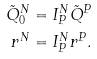Convert formula to latex. <formula><loc_0><loc_0><loc_500><loc_500>\tilde { Q } _ { 0 } ^ { N } & = I _ { P } ^ { N } \tilde { Q } ^ { P } \\ r ^ { N } & = I _ { P } ^ { N } r ^ { P } .</formula> 